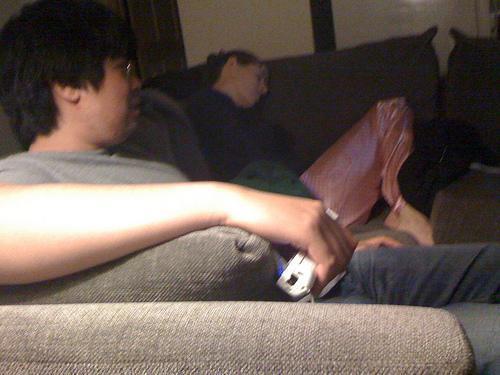How many people are there?
Give a very brief answer. 2. 